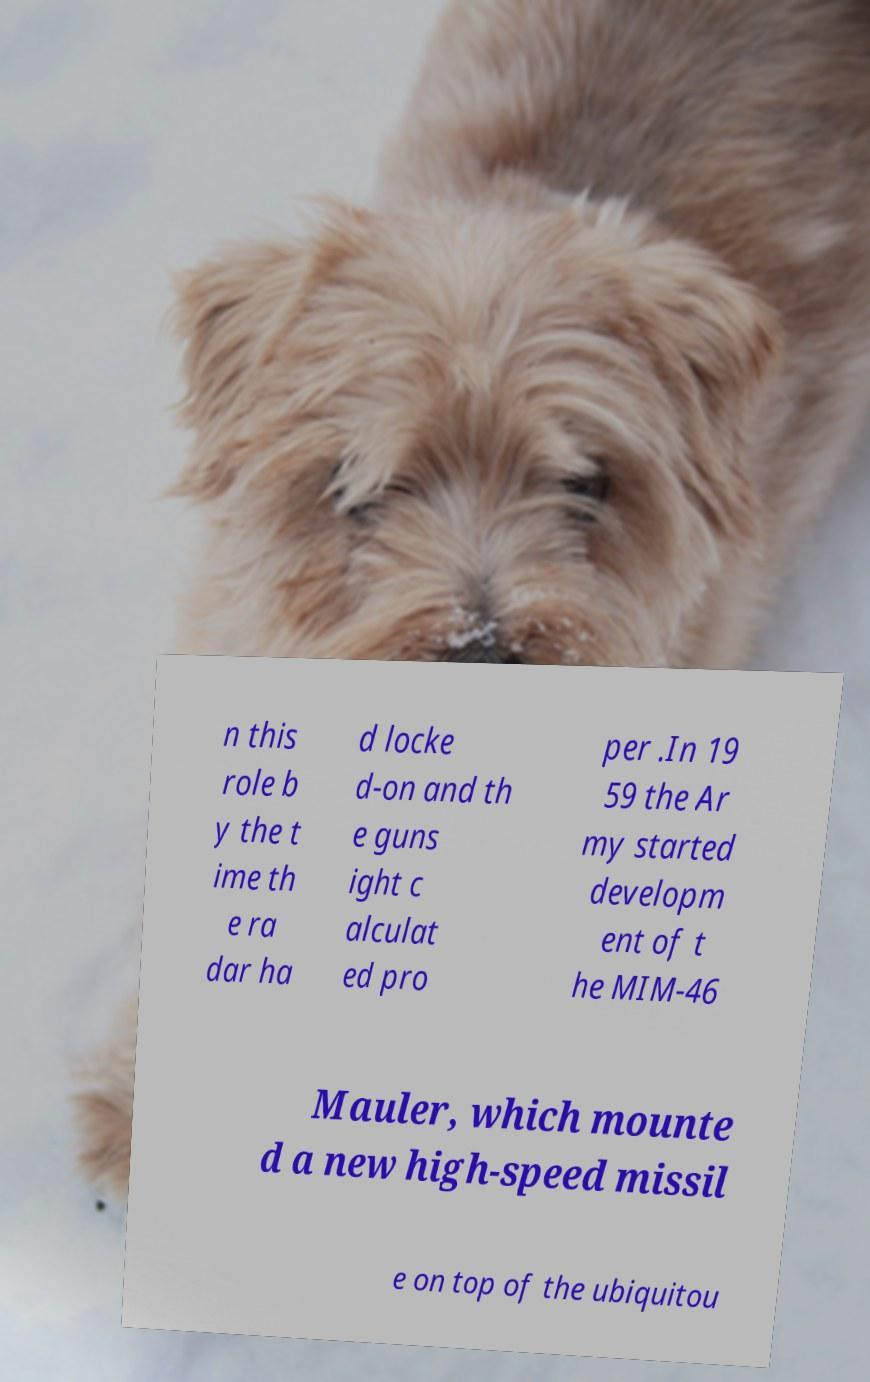For documentation purposes, I need the text within this image transcribed. Could you provide that? n this role b y the t ime th e ra dar ha d locke d-on and th e guns ight c alculat ed pro per .In 19 59 the Ar my started developm ent of t he MIM-46 Mauler, which mounte d a new high-speed missil e on top of the ubiquitou 